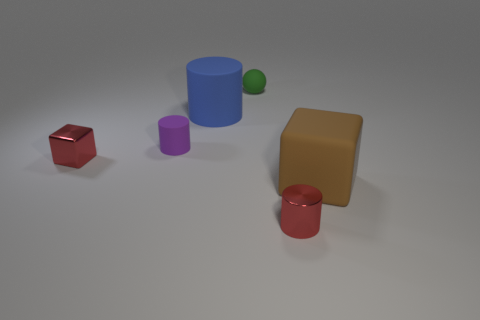There is another object that is the same shape as the brown object; what color is it?
Offer a very short reply. Red. What number of things are large blue objects in front of the small ball or metal things that are to the left of the tiny green rubber thing?
Provide a succinct answer. 2. What is the material of the small red cylinder?
Provide a short and direct response. Metal. How many other objects are there of the same size as the rubber cube?
Give a very brief answer. 1. There is a green rubber object that is right of the blue matte thing; what size is it?
Give a very brief answer. Small. There is a cube that is behind the rubber object that is on the right side of the tiny green rubber ball behind the large brown object; what is it made of?
Your response must be concise. Metal. Is the large brown matte object the same shape as the purple matte thing?
Make the answer very short. No. What number of rubber things are blue objects or tiny cylinders?
Make the answer very short. 2. How many brown matte spheres are there?
Ensure brevity in your answer.  0. There is a rubber thing that is the same size as the green ball; what is its color?
Your response must be concise. Purple. 